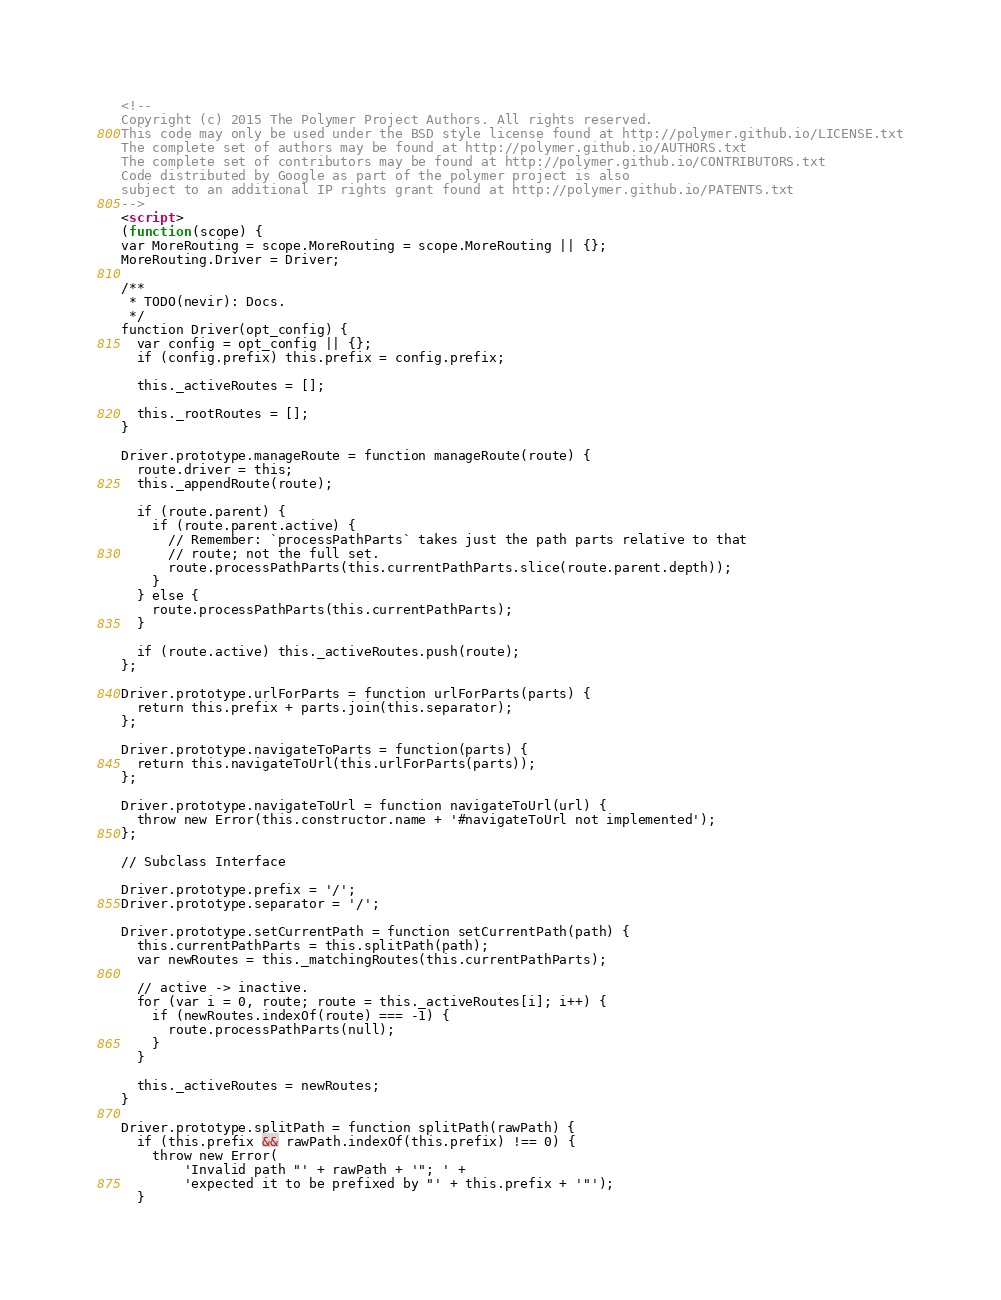Convert code to text. <code><loc_0><loc_0><loc_500><loc_500><_HTML_><!--
Copyright (c) 2015 The Polymer Project Authors. All rights reserved.
This code may only be used under the BSD style license found at http://polymer.github.io/LICENSE.txt
The complete set of authors may be found at http://polymer.github.io/AUTHORS.txt
The complete set of contributors may be found at http://polymer.github.io/CONTRIBUTORS.txt
Code distributed by Google as part of the polymer project is also
subject to an additional IP rights grant found at http://polymer.github.io/PATENTS.txt
-->
<script>
(function(scope) {
var MoreRouting = scope.MoreRouting = scope.MoreRouting || {};
MoreRouting.Driver = Driver;

/**
 * TODO(nevir): Docs.
 */
function Driver(opt_config) {
  var config = opt_config || {};
  if (config.prefix) this.prefix = config.prefix;

  this._activeRoutes = [];

  this._rootRoutes = [];
}

Driver.prototype.manageRoute = function manageRoute(route) {
  route.driver = this;
  this._appendRoute(route);

  if (route.parent) {
    if (route.parent.active) {
      // Remember: `processPathParts` takes just the path parts relative to that
      // route; not the full set.
      route.processPathParts(this.currentPathParts.slice(route.parent.depth));
    }
  } else {
    route.processPathParts(this.currentPathParts);
  }

  if (route.active) this._activeRoutes.push(route);
};

Driver.prototype.urlForParts = function urlForParts(parts) {
  return this.prefix + parts.join(this.separator);
};

Driver.prototype.navigateToParts = function(parts) {
  return this.navigateToUrl(this.urlForParts(parts));
};

Driver.prototype.navigateToUrl = function navigateToUrl(url) {
  throw new Error(this.constructor.name + '#navigateToUrl not implemented');
};

// Subclass Interface

Driver.prototype.prefix = '/';
Driver.prototype.separator = '/';

Driver.prototype.setCurrentPath = function setCurrentPath(path) {
  this.currentPathParts = this.splitPath(path);
  var newRoutes = this._matchingRoutes(this.currentPathParts);

  // active -> inactive.
  for (var i = 0, route; route = this._activeRoutes[i]; i++) {
    if (newRoutes.indexOf(route) === -1) {
      route.processPathParts(null);
    }
  }

  this._activeRoutes = newRoutes;
}

Driver.prototype.splitPath = function splitPath(rawPath) {
  if (this.prefix && rawPath.indexOf(this.prefix) !== 0) {
    throw new Error(
        'Invalid path "' + rawPath + '"; ' +
        'expected it to be prefixed by "' + this.prefix + '"');
  }</code> 